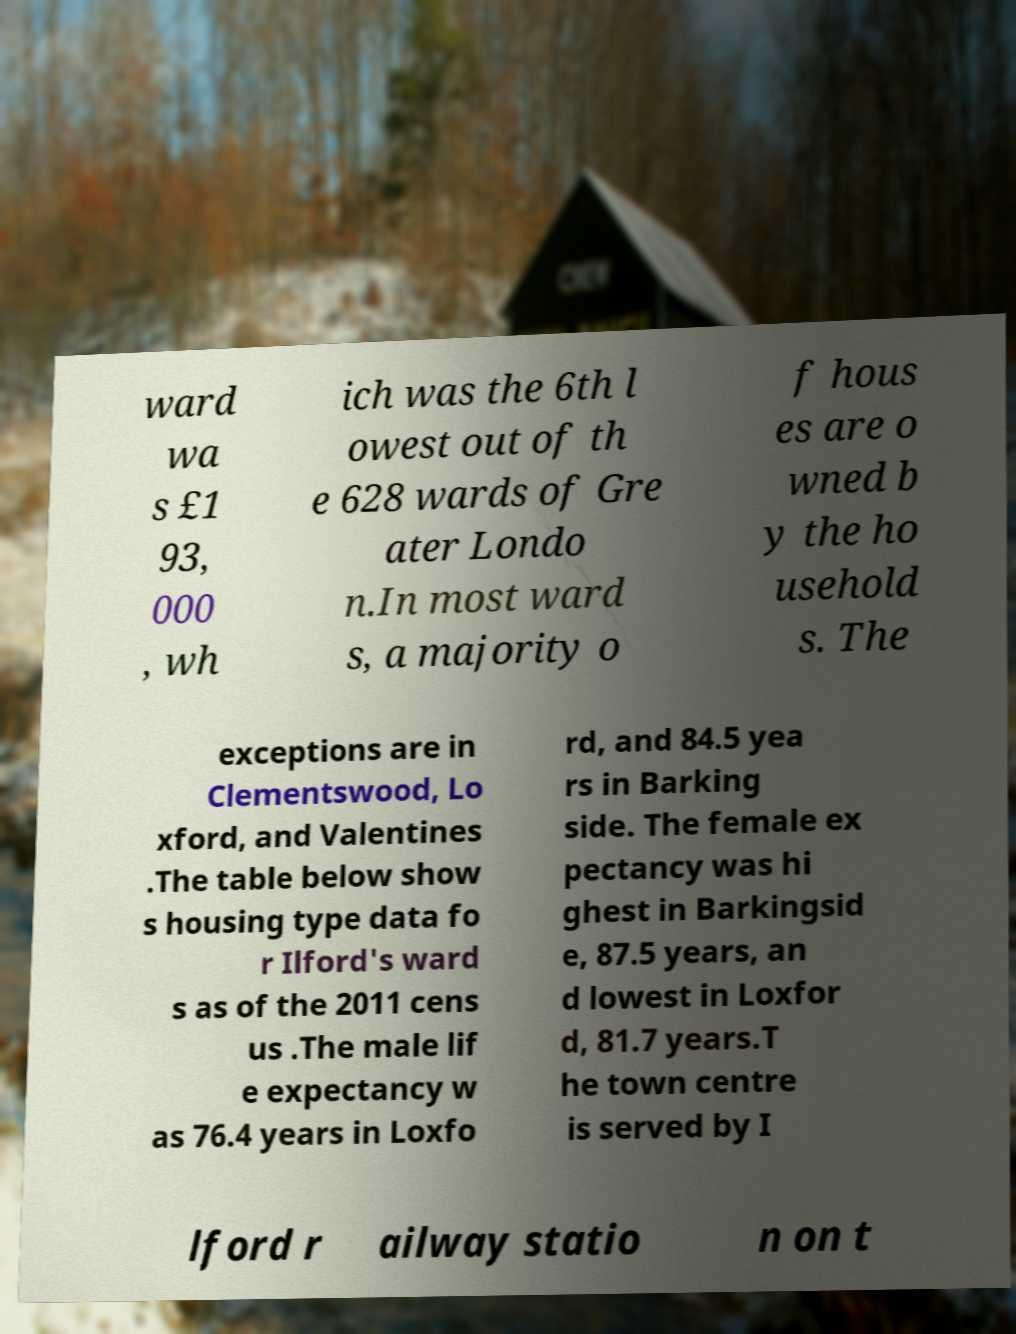For documentation purposes, I need the text within this image transcribed. Could you provide that? ward wa s £1 93, 000 , wh ich was the 6th l owest out of th e 628 wards of Gre ater Londo n.In most ward s, a majority o f hous es are o wned b y the ho usehold s. The exceptions are in Clementswood, Lo xford, and Valentines .The table below show s housing type data fo r Ilford's ward s as of the 2011 cens us .The male lif e expectancy w as 76.4 years in Loxfo rd, and 84.5 yea rs in Barking side. The female ex pectancy was hi ghest in Barkingsid e, 87.5 years, an d lowest in Loxfor d, 81.7 years.T he town centre is served by I lford r ailway statio n on t 